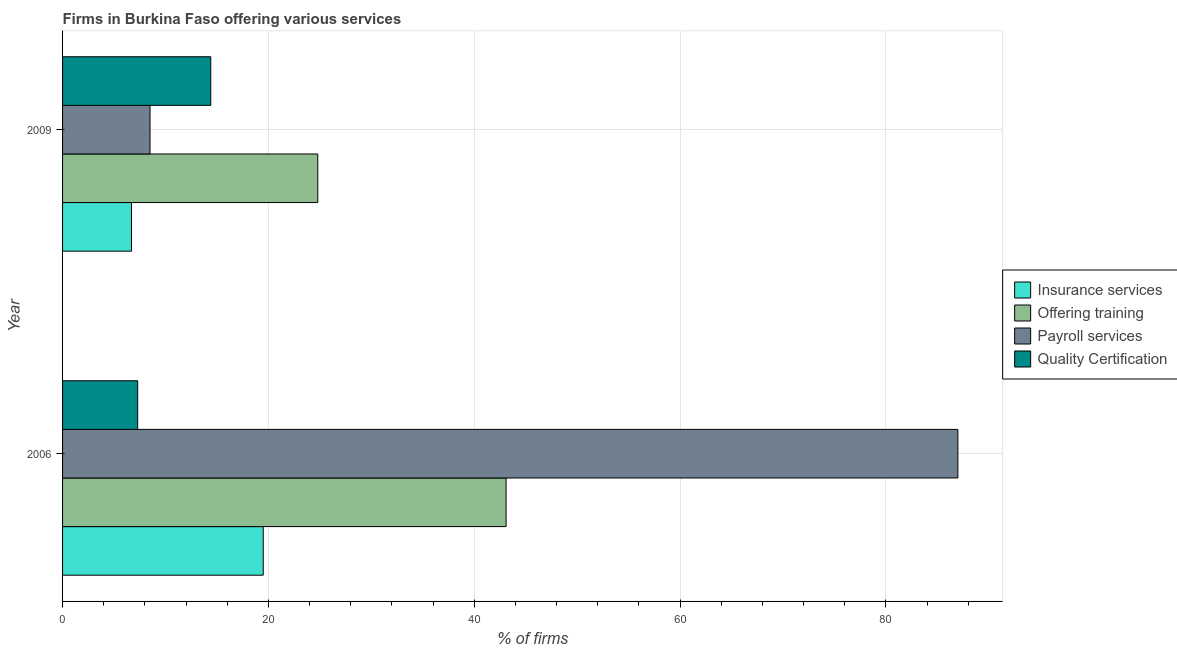How many groups of bars are there?
Your answer should be very brief. 2. Are the number of bars per tick equal to the number of legend labels?
Your response must be concise. Yes. How many bars are there on the 2nd tick from the top?
Your answer should be very brief. 4. How many bars are there on the 2nd tick from the bottom?
Ensure brevity in your answer.  4. In how many cases, is the number of bars for a given year not equal to the number of legend labels?
Provide a succinct answer. 0. What is the percentage of firms offering training in 2006?
Make the answer very short. 43.1. Across all years, what is the maximum percentage of firms offering payroll services?
Offer a very short reply. 87. Across all years, what is the minimum percentage of firms offering insurance services?
Provide a succinct answer. 6.7. In which year was the percentage of firms offering insurance services minimum?
Make the answer very short. 2009. What is the total percentage of firms offering quality certification in the graph?
Give a very brief answer. 21.7. What is the difference between the percentage of firms offering quality certification in 2006 and that in 2009?
Provide a short and direct response. -7.1. What is the difference between the percentage of firms offering insurance services in 2009 and the percentage of firms offering quality certification in 2006?
Make the answer very short. -0.6. In the year 2006, what is the difference between the percentage of firms offering payroll services and percentage of firms offering quality certification?
Provide a succinct answer. 79.7. What is the ratio of the percentage of firms offering insurance services in 2006 to that in 2009?
Provide a short and direct response. 2.91. In how many years, is the percentage of firms offering payroll services greater than the average percentage of firms offering payroll services taken over all years?
Provide a succinct answer. 1. What does the 3rd bar from the top in 2006 represents?
Your response must be concise. Offering training. What does the 1st bar from the bottom in 2009 represents?
Provide a succinct answer. Insurance services. How many bars are there?
Your response must be concise. 8. What is the difference between two consecutive major ticks on the X-axis?
Provide a succinct answer. 20. Does the graph contain grids?
Your answer should be compact. Yes. What is the title of the graph?
Your answer should be very brief. Firms in Burkina Faso offering various services . Does "Services" appear as one of the legend labels in the graph?
Provide a short and direct response. No. What is the label or title of the X-axis?
Keep it short and to the point. % of firms. What is the label or title of the Y-axis?
Your answer should be compact. Year. What is the % of firms of Offering training in 2006?
Keep it short and to the point. 43.1. What is the % of firms in Quality Certification in 2006?
Keep it short and to the point. 7.3. What is the % of firms in Insurance services in 2009?
Give a very brief answer. 6.7. What is the % of firms of Offering training in 2009?
Your answer should be compact. 24.8. Across all years, what is the maximum % of firms in Insurance services?
Your answer should be very brief. 19.5. Across all years, what is the maximum % of firms of Offering training?
Your response must be concise. 43.1. Across all years, what is the maximum % of firms in Payroll services?
Provide a succinct answer. 87. Across all years, what is the minimum % of firms in Offering training?
Provide a short and direct response. 24.8. Across all years, what is the minimum % of firms in Payroll services?
Your answer should be compact. 8.5. What is the total % of firms in Insurance services in the graph?
Your answer should be compact. 26.2. What is the total % of firms of Offering training in the graph?
Provide a succinct answer. 67.9. What is the total % of firms in Payroll services in the graph?
Make the answer very short. 95.5. What is the total % of firms in Quality Certification in the graph?
Your answer should be compact. 21.7. What is the difference between the % of firms of Insurance services in 2006 and that in 2009?
Give a very brief answer. 12.8. What is the difference between the % of firms of Offering training in 2006 and that in 2009?
Give a very brief answer. 18.3. What is the difference between the % of firms in Payroll services in 2006 and that in 2009?
Give a very brief answer. 78.5. What is the difference between the % of firms of Insurance services in 2006 and the % of firms of Offering training in 2009?
Offer a terse response. -5.3. What is the difference between the % of firms in Insurance services in 2006 and the % of firms in Payroll services in 2009?
Offer a very short reply. 11. What is the difference between the % of firms of Offering training in 2006 and the % of firms of Payroll services in 2009?
Offer a terse response. 34.6. What is the difference between the % of firms of Offering training in 2006 and the % of firms of Quality Certification in 2009?
Ensure brevity in your answer.  28.7. What is the difference between the % of firms in Payroll services in 2006 and the % of firms in Quality Certification in 2009?
Provide a short and direct response. 72.6. What is the average % of firms of Offering training per year?
Make the answer very short. 33.95. What is the average % of firms in Payroll services per year?
Your answer should be compact. 47.75. What is the average % of firms of Quality Certification per year?
Your response must be concise. 10.85. In the year 2006, what is the difference between the % of firms in Insurance services and % of firms in Offering training?
Make the answer very short. -23.6. In the year 2006, what is the difference between the % of firms in Insurance services and % of firms in Payroll services?
Ensure brevity in your answer.  -67.5. In the year 2006, what is the difference between the % of firms in Insurance services and % of firms in Quality Certification?
Offer a very short reply. 12.2. In the year 2006, what is the difference between the % of firms of Offering training and % of firms of Payroll services?
Your response must be concise. -43.9. In the year 2006, what is the difference between the % of firms in Offering training and % of firms in Quality Certification?
Your answer should be compact. 35.8. In the year 2006, what is the difference between the % of firms of Payroll services and % of firms of Quality Certification?
Your answer should be compact. 79.7. In the year 2009, what is the difference between the % of firms of Insurance services and % of firms of Offering training?
Give a very brief answer. -18.1. In the year 2009, what is the difference between the % of firms in Payroll services and % of firms in Quality Certification?
Make the answer very short. -5.9. What is the ratio of the % of firms in Insurance services in 2006 to that in 2009?
Make the answer very short. 2.91. What is the ratio of the % of firms in Offering training in 2006 to that in 2009?
Ensure brevity in your answer.  1.74. What is the ratio of the % of firms in Payroll services in 2006 to that in 2009?
Offer a very short reply. 10.24. What is the ratio of the % of firms of Quality Certification in 2006 to that in 2009?
Provide a short and direct response. 0.51. What is the difference between the highest and the second highest % of firms of Payroll services?
Ensure brevity in your answer.  78.5. What is the difference between the highest and the second highest % of firms of Quality Certification?
Your answer should be compact. 7.1. What is the difference between the highest and the lowest % of firms of Payroll services?
Your response must be concise. 78.5. 